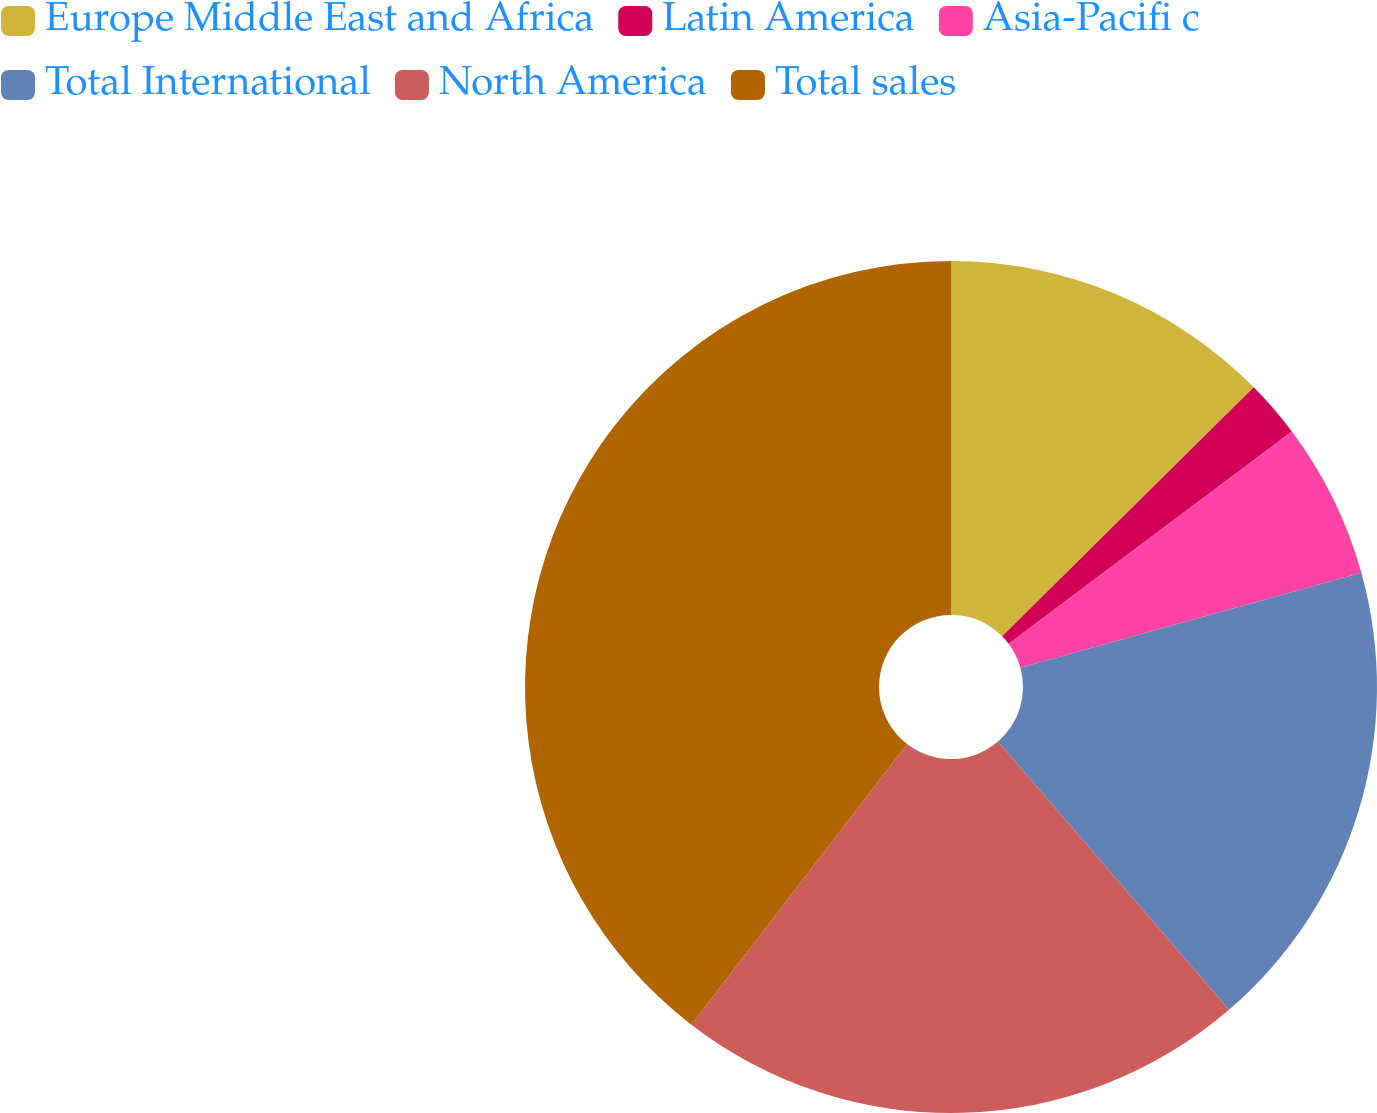Convert chart to OTSL. <chart><loc_0><loc_0><loc_500><loc_500><pie_chart><fcel>Europe Middle East and Africa<fcel>Latin America<fcel>Asia-Pacifi c<fcel>Total International<fcel>North America<fcel>Total sales<nl><fcel>12.58%<fcel>2.18%<fcel>5.92%<fcel>18.01%<fcel>21.75%<fcel>39.57%<nl></chart> 